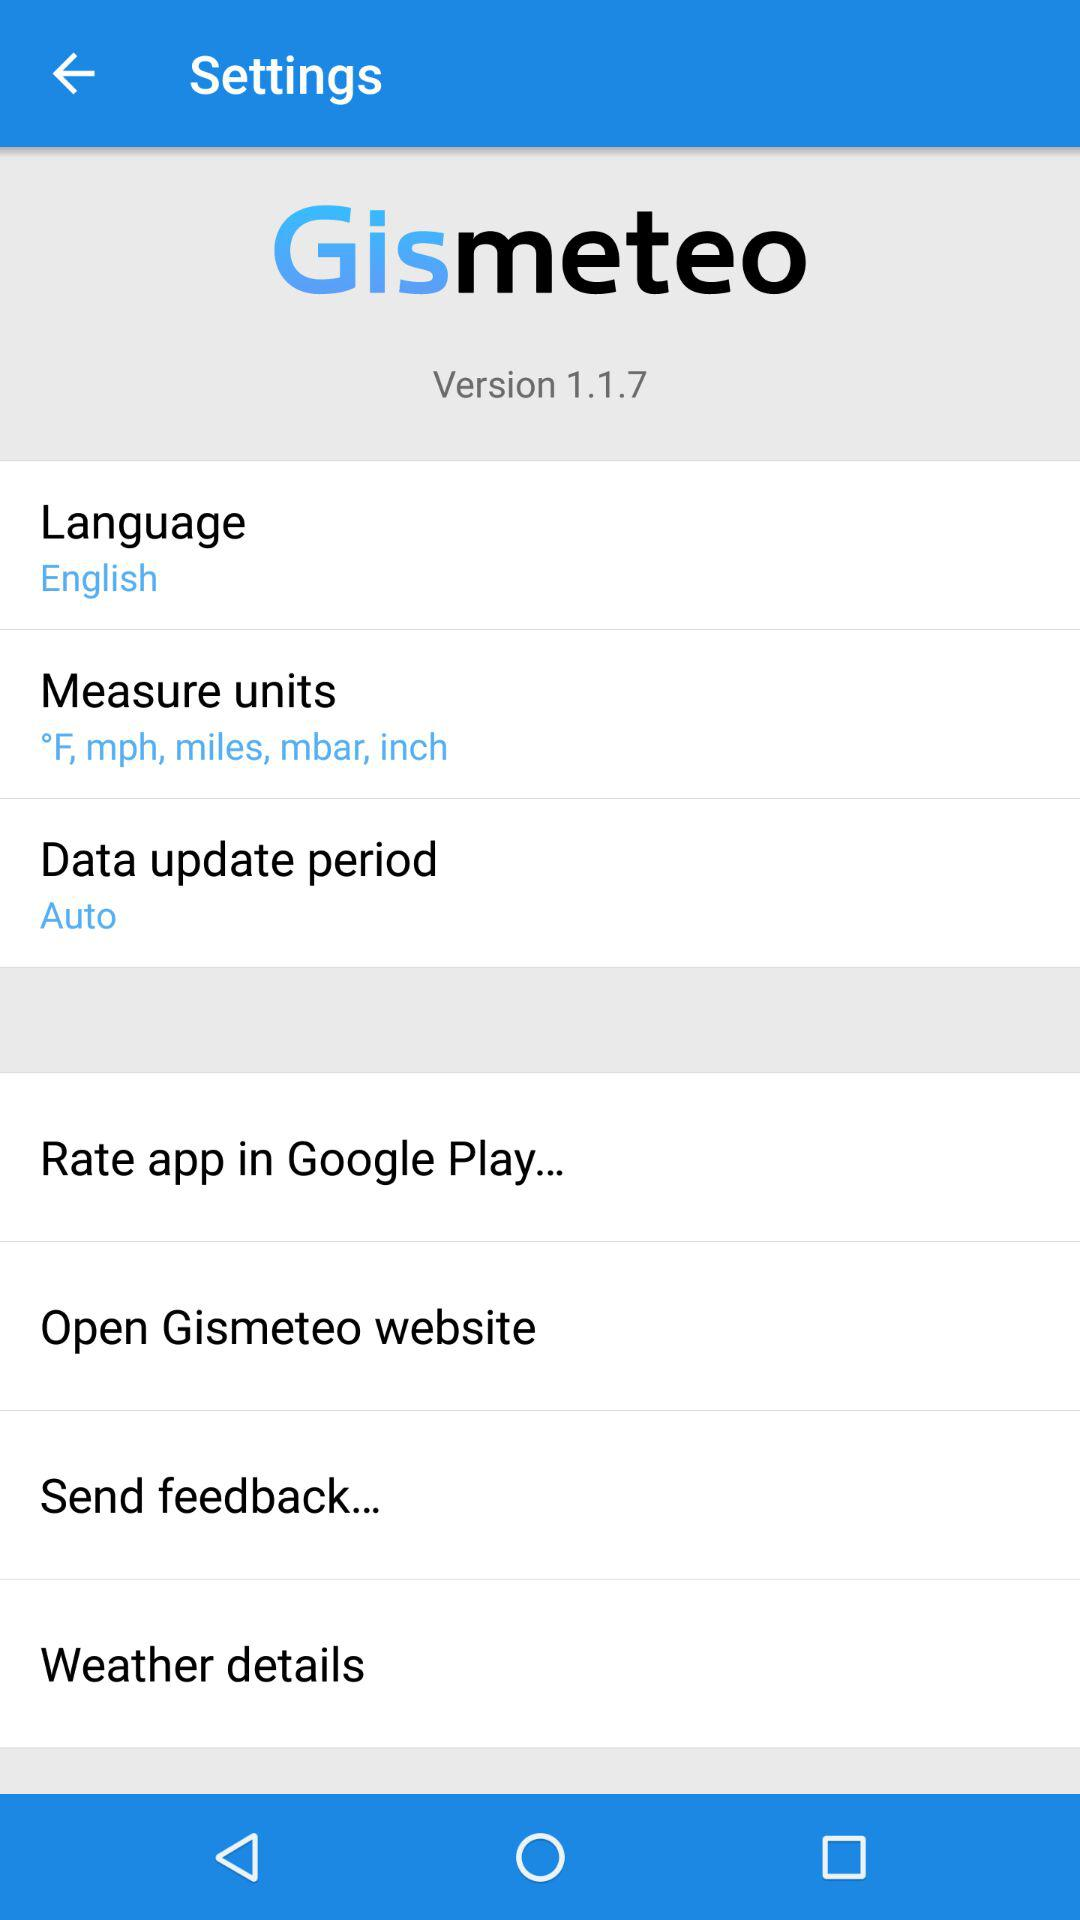What is the version of the application? The version of the application is 1.1.7. 